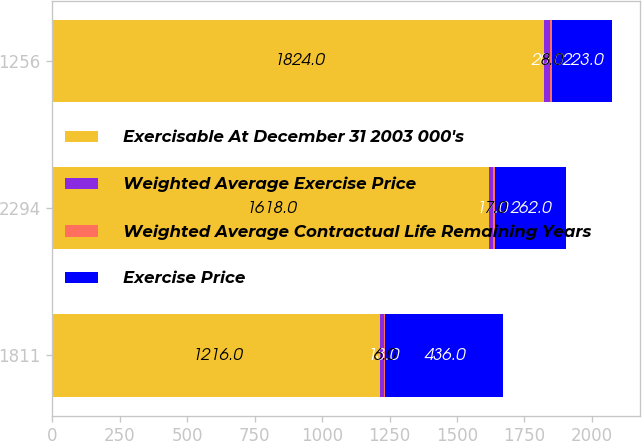<chart> <loc_0><loc_0><loc_500><loc_500><stacked_bar_chart><ecel><fcel>1811<fcel>2294<fcel>1256<nl><fcel>Exercisable At December 31 2003 000's<fcel>1216<fcel>1618<fcel>1824<nl><fcel>Weighted Average Exercise Price<fcel>13<fcel>17<fcel>20<nl><fcel>Weighted Average Contractual Life Remaining Years<fcel>6<fcel>7<fcel>8<nl><fcel>Exercise Price<fcel>436<fcel>262<fcel>223<nl></chart> 